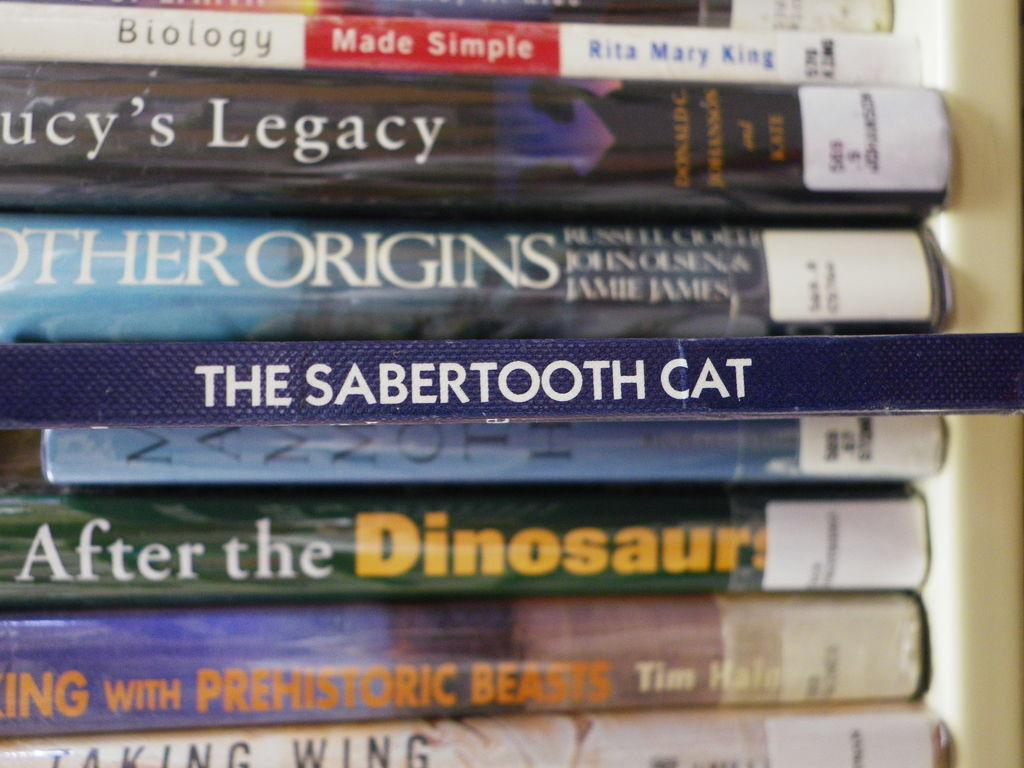<image>
Present a compact description of the photo's key features. A book called After the Dinosaurs sits near The Sabertooth Cat. 